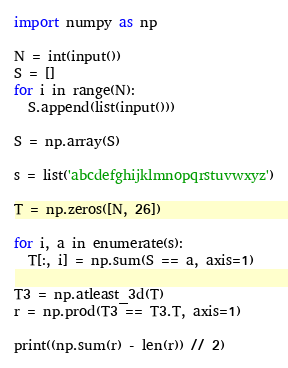<code> <loc_0><loc_0><loc_500><loc_500><_Python_>import numpy as np

N = int(input())
S = []
for i in range(N):
  S.append(list(input()))

S = np.array(S)

s = list('abcdefghijklmnopqrstuvwxyz')

T = np.zeros([N, 26])

for i, a in enumerate(s):
  T[:, i] = np.sum(S == a, axis=1)

T3 = np.atleast_3d(T)
r = np.prod(T3 == T3.T, axis=1)

print((np.sum(r) - len(r)) // 2)</code> 